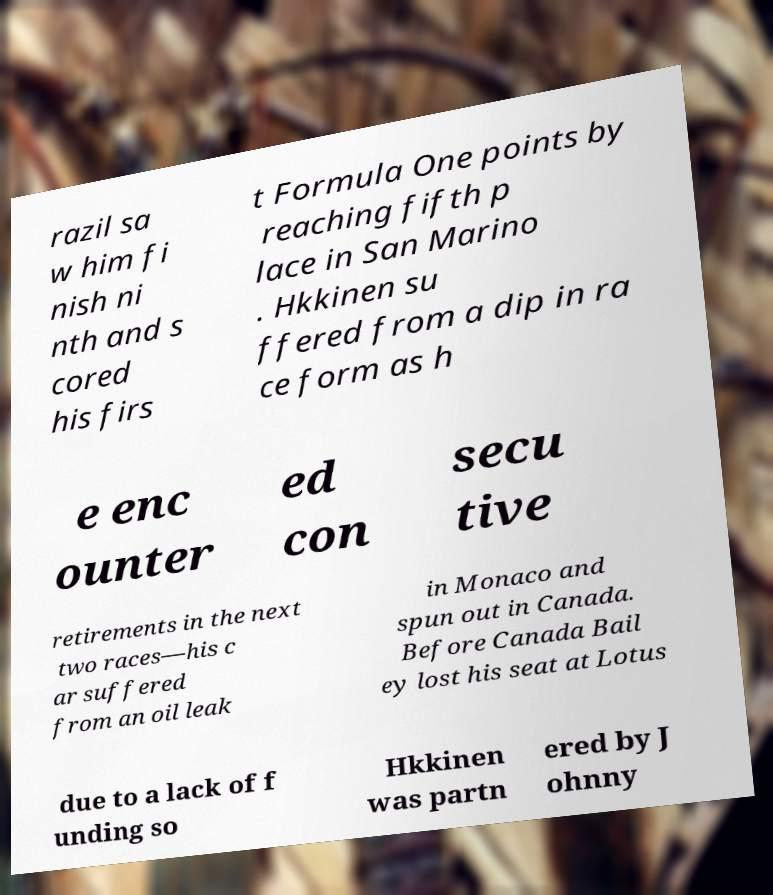Can you read and provide the text displayed in the image?This photo seems to have some interesting text. Can you extract and type it out for me? razil sa w him fi nish ni nth and s cored his firs t Formula One points by reaching fifth p lace in San Marino . Hkkinen su ffered from a dip in ra ce form as h e enc ounter ed con secu tive retirements in the next two races—his c ar suffered from an oil leak in Monaco and spun out in Canada. Before Canada Bail ey lost his seat at Lotus due to a lack of f unding so Hkkinen was partn ered by J ohnny 